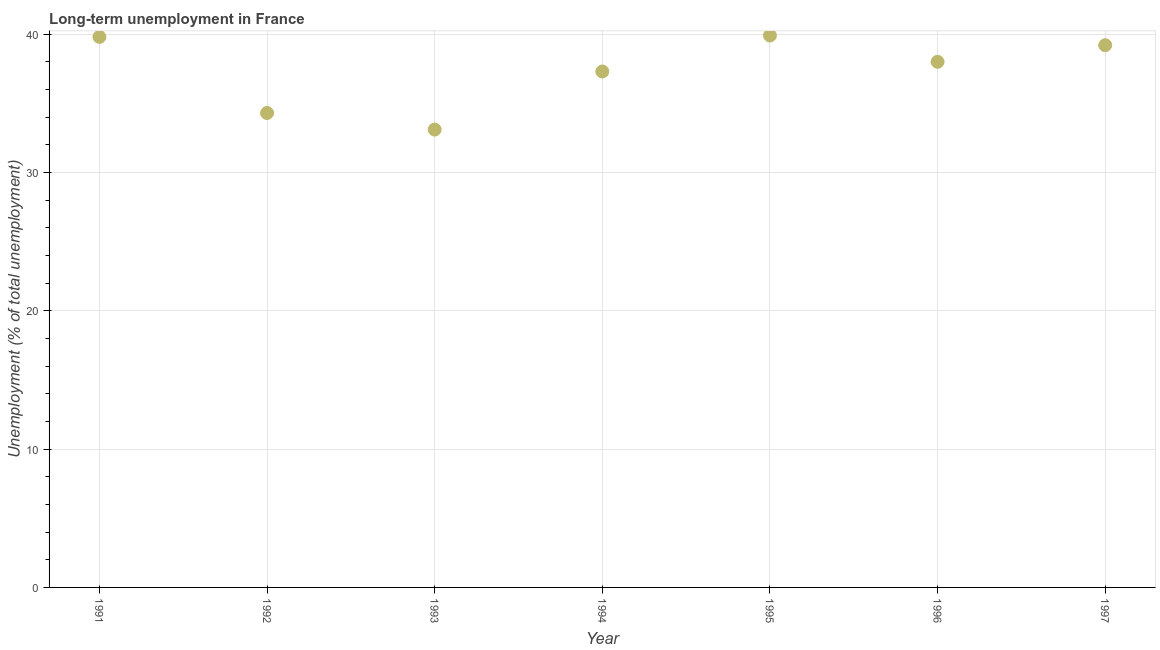What is the long-term unemployment in 1992?
Provide a short and direct response. 34.3. Across all years, what is the maximum long-term unemployment?
Provide a succinct answer. 39.9. Across all years, what is the minimum long-term unemployment?
Offer a terse response. 33.1. In which year was the long-term unemployment minimum?
Offer a terse response. 1993. What is the sum of the long-term unemployment?
Keep it short and to the point. 261.6. What is the difference between the long-term unemployment in 1992 and 1995?
Give a very brief answer. -5.6. What is the average long-term unemployment per year?
Ensure brevity in your answer.  37.37. What is the ratio of the long-term unemployment in 1992 to that in 1993?
Your answer should be compact. 1.04. Is the difference between the long-term unemployment in 1996 and 1997 greater than the difference between any two years?
Ensure brevity in your answer.  No. What is the difference between the highest and the second highest long-term unemployment?
Your answer should be very brief. 0.1. Is the sum of the long-term unemployment in 1991 and 1992 greater than the maximum long-term unemployment across all years?
Offer a terse response. Yes. What is the difference between the highest and the lowest long-term unemployment?
Your answer should be very brief. 6.8. In how many years, is the long-term unemployment greater than the average long-term unemployment taken over all years?
Your answer should be very brief. 4. Does the long-term unemployment monotonically increase over the years?
Make the answer very short. No. How many years are there in the graph?
Provide a succinct answer. 7. Does the graph contain any zero values?
Give a very brief answer. No. Does the graph contain grids?
Make the answer very short. Yes. What is the title of the graph?
Offer a very short reply. Long-term unemployment in France. What is the label or title of the X-axis?
Keep it short and to the point. Year. What is the label or title of the Y-axis?
Make the answer very short. Unemployment (% of total unemployment). What is the Unemployment (% of total unemployment) in 1991?
Your response must be concise. 39.8. What is the Unemployment (% of total unemployment) in 1992?
Offer a terse response. 34.3. What is the Unemployment (% of total unemployment) in 1993?
Provide a short and direct response. 33.1. What is the Unemployment (% of total unemployment) in 1994?
Your response must be concise. 37.3. What is the Unemployment (% of total unemployment) in 1995?
Provide a short and direct response. 39.9. What is the Unemployment (% of total unemployment) in 1997?
Your response must be concise. 39.2. What is the difference between the Unemployment (% of total unemployment) in 1991 and 1996?
Keep it short and to the point. 1.8. What is the difference between the Unemployment (% of total unemployment) in 1991 and 1997?
Keep it short and to the point. 0.6. What is the difference between the Unemployment (% of total unemployment) in 1992 and 1995?
Provide a succinct answer. -5.6. What is the difference between the Unemployment (% of total unemployment) in 1992 and 1996?
Your response must be concise. -3.7. What is the difference between the Unemployment (% of total unemployment) in 1993 and 1995?
Your answer should be very brief. -6.8. What is the difference between the Unemployment (% of total unemployment) in 1993 and 1996?
Provide a succinct answer. -4.9. What is the ratio of the Unemployment (% of total unemployment) in 1991 to that in 1992?
Ensure brevity in your answer.  1.16. What is the ratio of the Unemployment (% of total unemployment) in 1991 to that in 1993?
Give a very brief answer. 1.2. What is the ratio of the Unemployment (% of total unemployment) in 1991 to that in 1994?
Provide a succinct answer. 1.07. What is the ratio of the Unemployment (% of total unemployment) in 1991 to that in 1996?
Your answer should be compact. 1.05. What is the ratio of the Unemployment (% of total unemployment) in 1992 to that in 1993?
Give a very brief answer. 1.04. What is the ratio of the Unemployment (% of total unemployment) in 1992 to that in 1994?
Ensure brevity in your answer.  0.92. What is the ratio of the Unemployment (% of total unemployment) in 1992 to that in 1995?
Provide a short and direct response. 0.86. What is the ratio of the Unemployment (% of total unemployment) in 1992 to that in 1996?
Ensure brevity in your answer.  0.9. What is the ratio of the Unemployment (% of total unemployment) in 1993 to that in 1994?
Your answer should be very brief. 0.89. What is the ratio of the Unemployment (% of total unemployment) in 1993 to that in 1995?
Give a very brief answer. 0.83. What is the ratio of the Unemployment (% of total unemployment) in 1993 to that in 1996?
Keep it short and to the point. 0.87. What is the ratio of the Unemployment (% of total unemployment) in 1993 to that in 1997?
Make the answer very short. 0.84. What is the ratio of the Unemployment (% of total unemployment) in 1994 to that in 1995?
Keep it short and to the point. 0.94. What is the ratio of the Unemployment (% of total unemployment) in 1995 to that in 1997?
Make the answer very short. 1.02. 